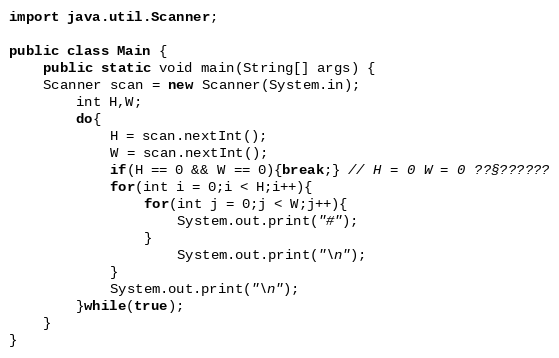<code> <loc_0><loc_0><loc_500><loc_500><_Java_>import java.util.Scanner;

public class Main {
    public static void main(String[] args) {
	Scanner scan = new Scanner(System.in);
		int H,W;
		do{
			H = scan.nextInt();
			W = scan.nextInt();
			if(H == 0 && W == 0){break;} // H = 0 W = 0 ??§??????
			for(int i = 0;i < H;i++){
				for(int j = 0;j < W;j++){
					System.out.print("#");
				}
					System.out.print("\n");
			}
			System.out.print("\n");	
		}while(true);
	}
}</code> 